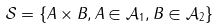<formula> <loc_0><loc_0><loc_500><loc_500>\mathcal { S } = \{ A \times B , A \in \mathcal { A } _ { 1 } , B \in \mathcal { A } _ { 2 } \}</formula> 